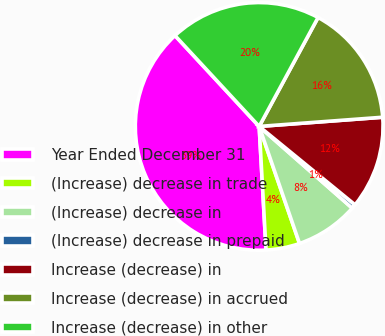Convert chart. <chart><loc_0><loc_0><loc_500><loc_500><pie_chart><fcel>Year Ended December 31<fcel>(Increase) decrease in trade<fcel>(Increase) decrease in<fcel>(Increase) decrease in prepaid<fcel>Increase (decrease) in<fcel>Increase (decrease) in accrued<fcel>Increase (decrease) in other<nl><fcel>38.99%<fcel>4.4%<fcel>8.25%<fcel>0.56%<fcel>12.09%<fcel>15.93%<fcel>19.78%<nl></chart> 